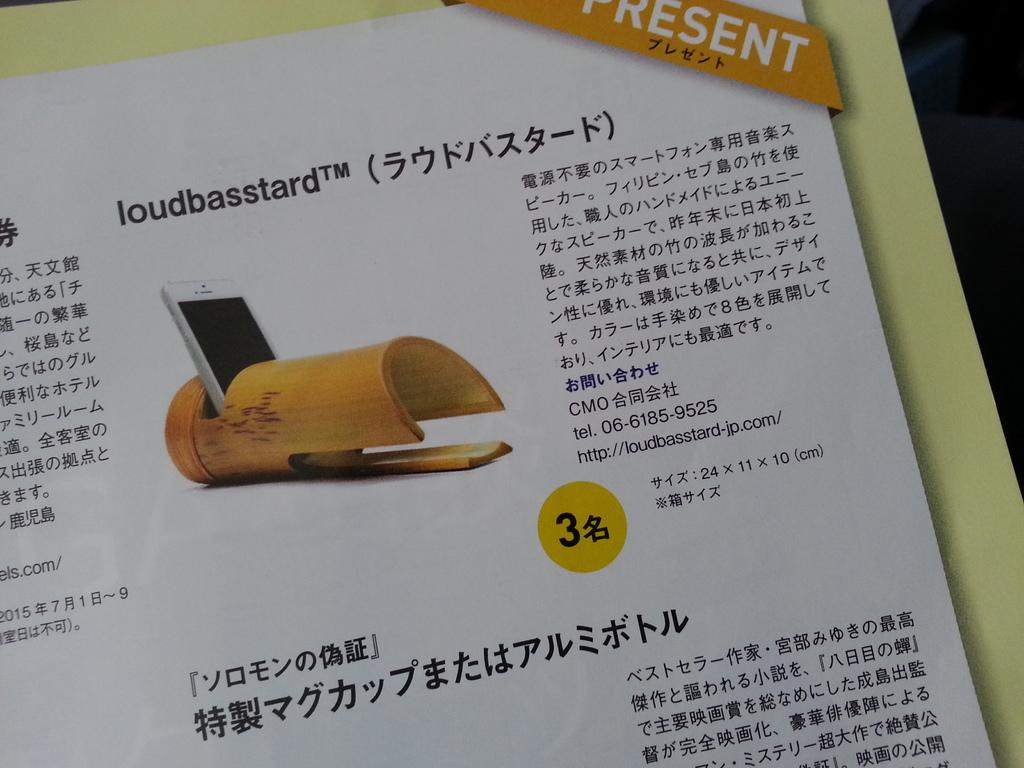<image>
Present a compact description of the photo's key features. An advertisement in an Asian language, item is called loudbasstard. 